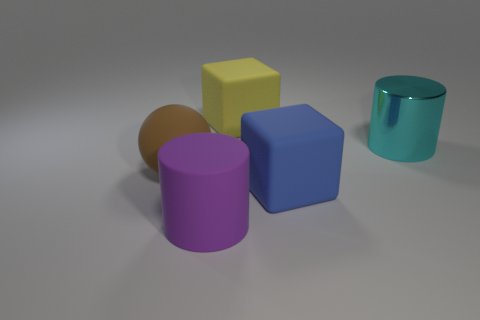Add 2 big rubber spheres. How many objects exist? 7 Subtract all yellow blocks. How many blocks are left? 1 Subtract 1 spheres. How many spheres are left? 0 Subtract all purple spheres. How many gray cylinders are left? 0 Subtract all small blue metallic things. Subtract all blue rubber cubes. How many objects are left? 4 Add 1 big cylinders. How many big cylinders are left? 3 Add 3 large metal cylinders. How many large metal cylinders exist? 4 Subtract 0 red balls. How many objects are left? 5 Subtract all cubes. How many objects are left? 3 Subtract all blue cubes. Subtract all brown spheres. How many cubes are left? 1 